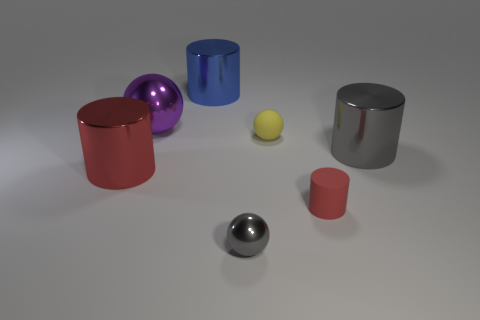Subtract all gray cubes. How many red cylinders are left? 2 Subtract all small red cylinders. How many cylinders are left? 3 Add 3 large brown blocks. How many objects exist? 10 Subtract 1 cylinders. How many cylinders are left? 3 Subtract all blue cylinders. How many cylinders are left? 3 Subtract all balls. How many objects are left? 4 Add 1 large gray shiny things. How many large gray shiny things exist? 2 Subtract 0 yellow blocks. How many objects are left? 7 Subtract all cyan cylinders. Subtract all red balls. How many cylinders are left? 4 Subtract all tiny red matte cylinders. Subtract all red metal blocks. How many objects are left? 6 